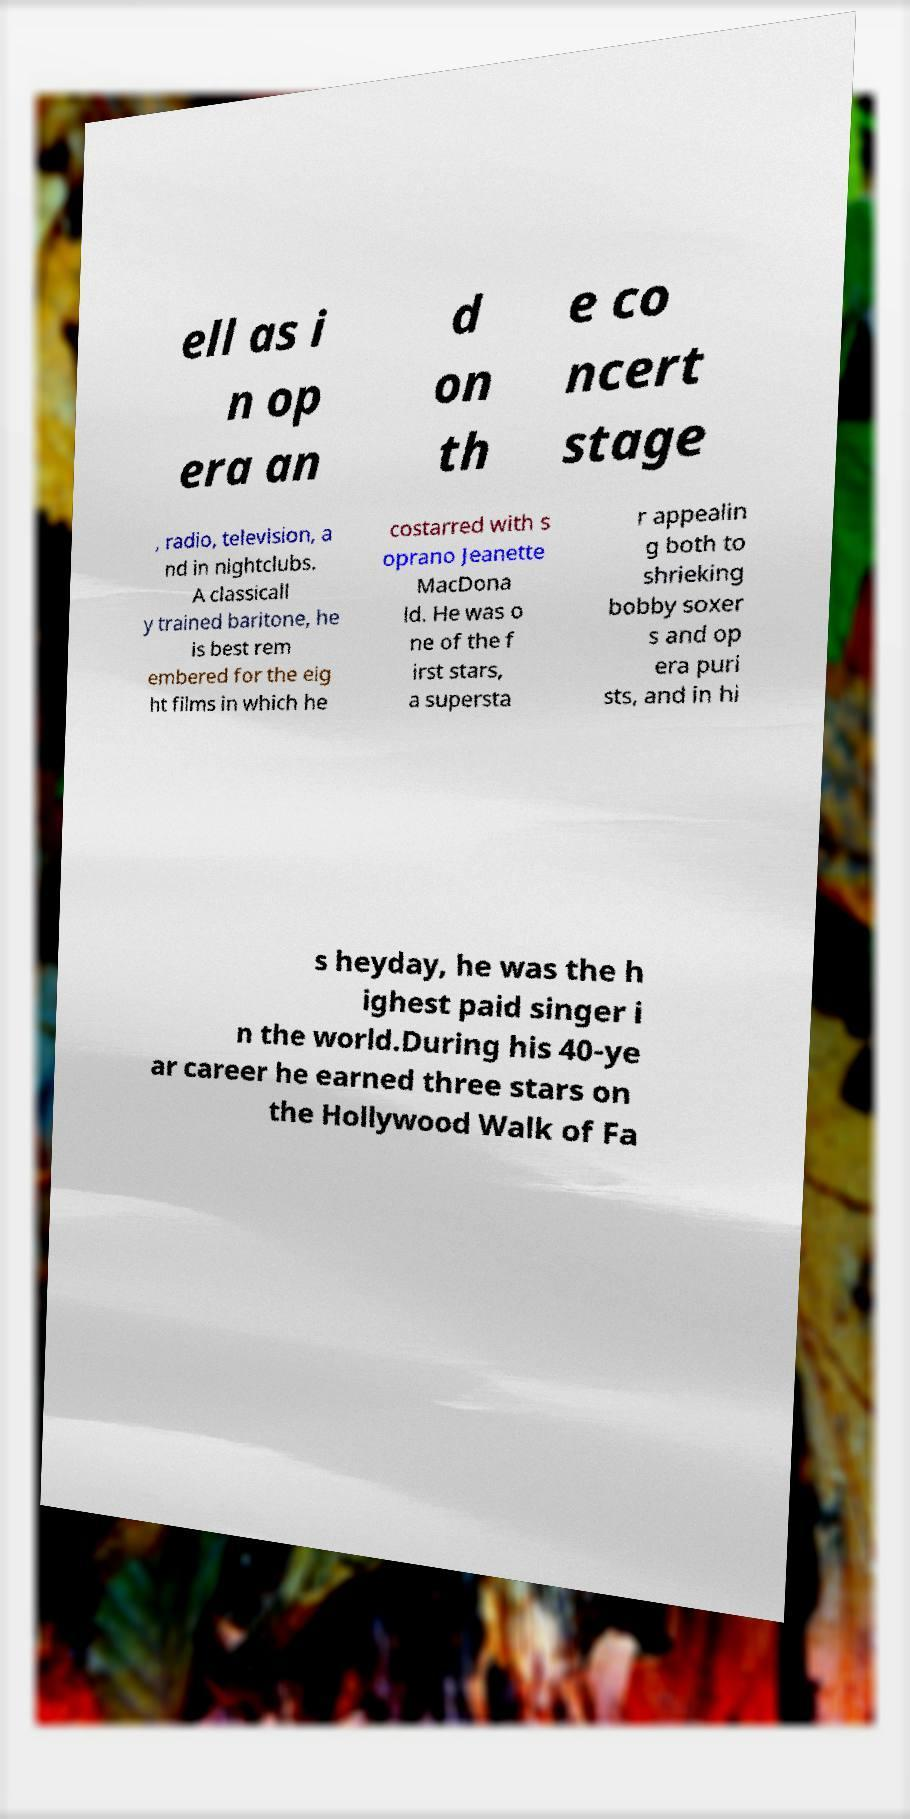Could you extract and type out the text from this image? ell as i n op era an d on th e co ncert stage , radio, television, a nd in nightclubs. A classicall y trained baritone, he is best rem embered for the eig ht films in which he costarred with s oprano Jeanette MacDona ld. He was o ne of the f irst stars, a supersta r appealin g both to shrieking bobby soxer s and op era puri sts, and in hi s heyday, he was the h ighest paid singer i n the world.During his 40-ye ar career he earned three stars on the Hollywood Walk of Fa 